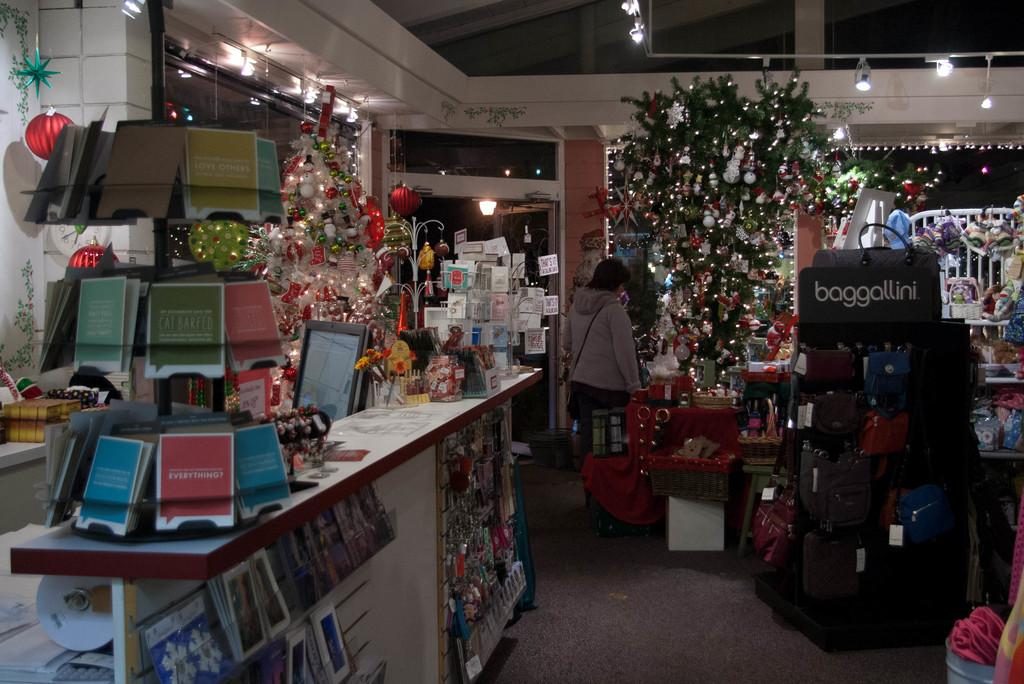<image>
Relay a brief, clear account of the picture shown. Inside a convenience store that has many products to sell including baggallini. 